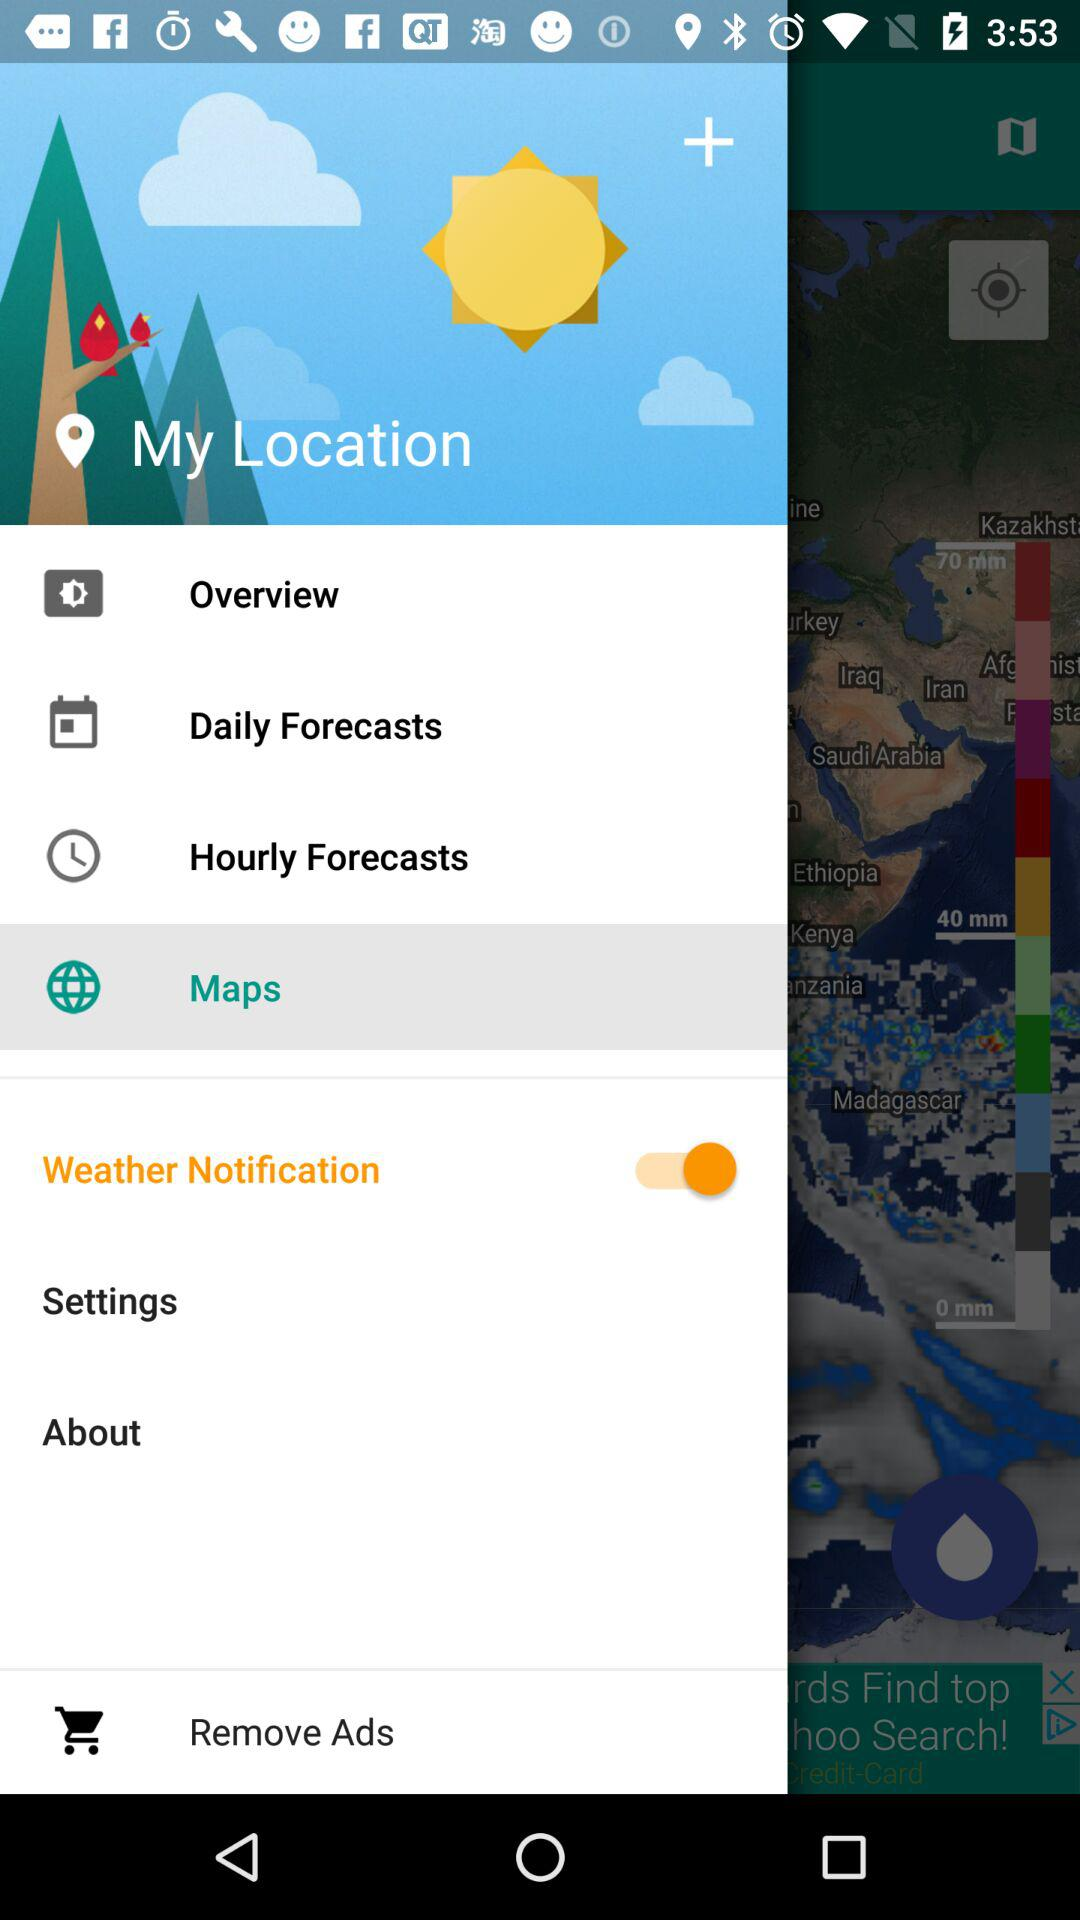What is the status of "Weather Notification"? The status is "on". 